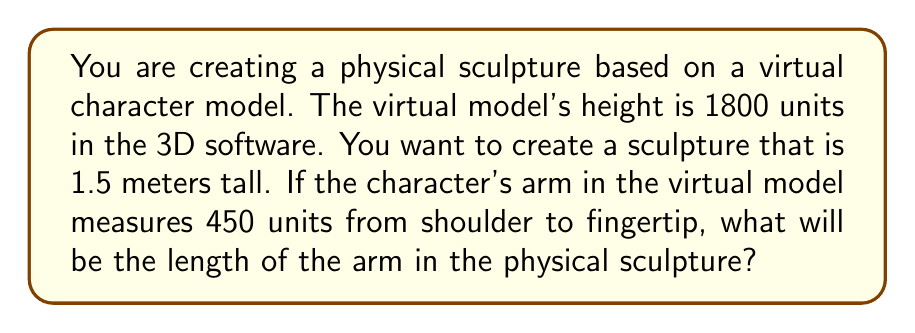Solve this math problem. To solve this problem, we need to determine the scaling factor and then apply it to the arm measurement. Let's break it down step by step:

1. Determine the scaling factor:
   - Virtual model height: 1800 units
   - Desired physical sculpture height: 1.5 meters = 150 cm
   
   Scaling factor = $\frac{\text{Physical size}}{\text{Virtual size}}$
   
   $$\text{Scaling factor} = \frac{150 \text{ cm}}{1800 \text{ units}} = \frac{1}{12} = 0.0833333...$$

2. Apply the scaling factor to the arm measurement:
   - Virtual arm length: 450 units
   - Scaling factor: $\frac{1}{12}$
   
   $$\text{Physical arm length} = 450 \text{ units} \times \frac{1}{12} = 37.5 \text{ cm}$$

Therefore, the arm in the physical sculpture will be 37.5 cm long.

We can verify this result using the proportion:

$$\frac{\text{Virtual height}}{\text{Virtual arm length}} = \frac{\text{Physical height}}{\text{Physical arm length}}$$

$$\frac{1800}{450} = \frac{150}{\text{x}}$$

$$4 = \frac{150}{\text{x}}$$

$$\text{x} = \frac{150}{4} = 37.5 \text{ cm}$$

This confirms our calculated result.
Answer: The length of the arm in the physical sculpture will be 37.5 cm. 